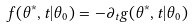<formula> <loc_0><loc_0><loc_500><loc_500>f ( \theta ^ { * } , t | \theta _ { 0 } ) = - \partial _ { t } g ( \theta ^ { * } , t | \theta _ { 0 } )</formula> 